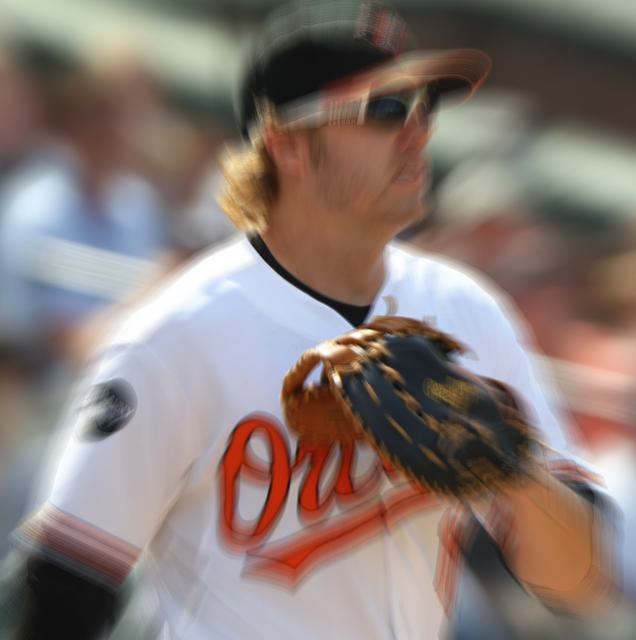What emotions does the image evoke considering the motion blur? The motion blur creates a dynamic and intense atmosphere, suggesting the fast-paced nature of sports events. It can evoke feelings of excitement and anticipation, as viewers may imagine the split-second actions taking place on the field, such as a critical catch or throw in a high-stakes moment of the game. 